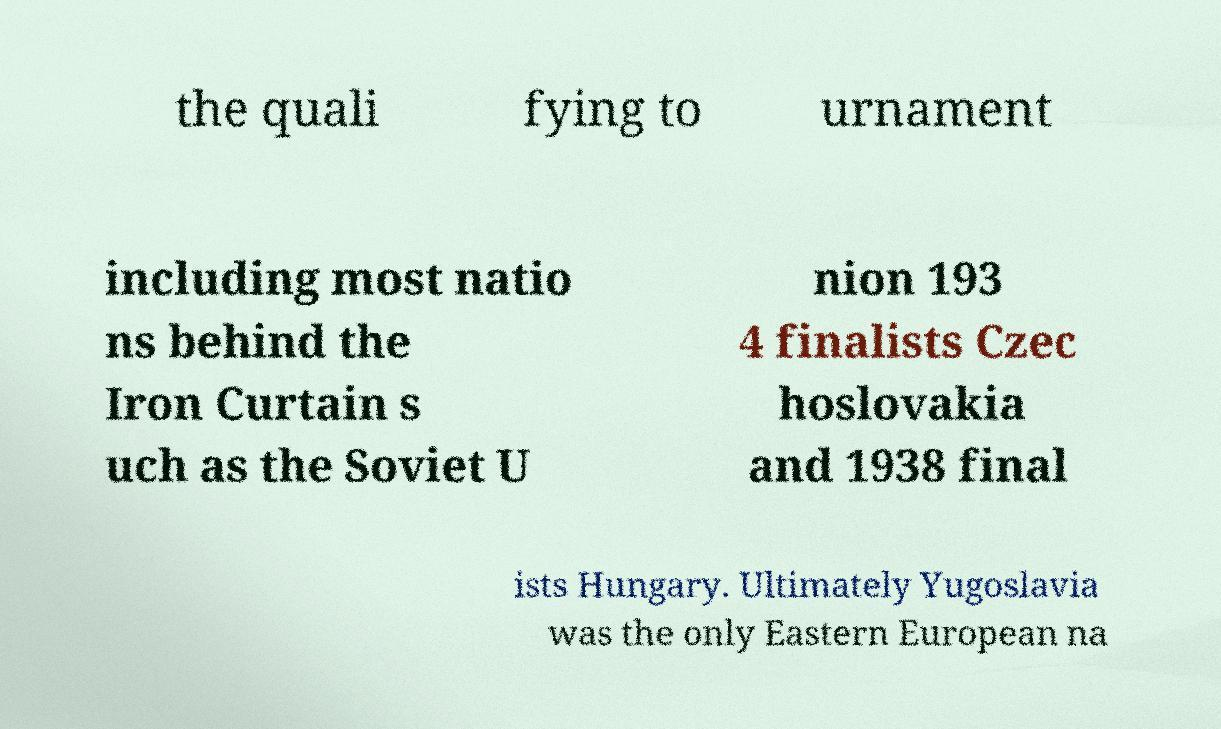Can you read and provide the text displayed in the image?This photo seems to have some interesting text. Can you extract and type it out for me? the quali fying to urnament including most natio ns behind the Iron Curtain s uch as the Soviet U nion 193 4 finalists Czec hoslovakia and 1938 final ists Hungary. Ultimately Yugoslavia was the only Eastern European na 